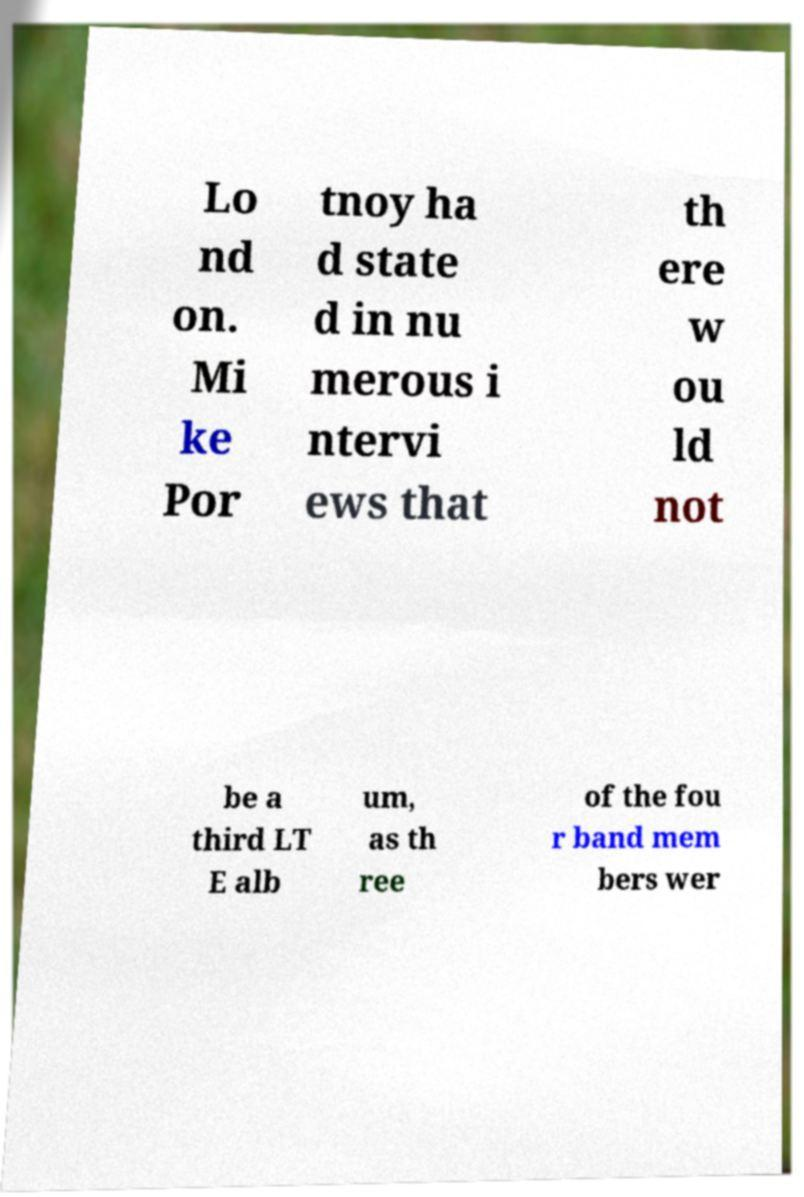Can you read and provide the text displayed in the image?This photo seems to have some interesting text. Can you extract and type it out for me? Lo nd on. Mi ke Por tnoy ha d state d in nu merous i ntervi ews that th ere w ou ld not be a third LT E alb um, as th ree of the fou r band mem bers wer 